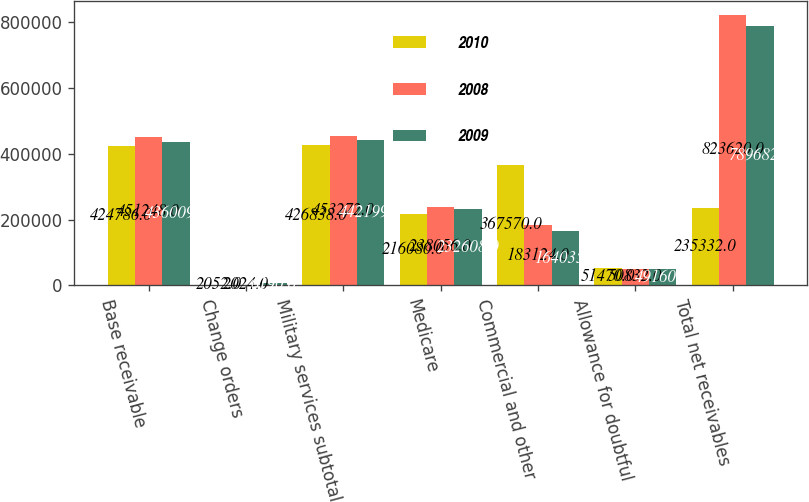<chart> <loc_0><loc_0><loc_500><loc_500><stacked_bar_chart><ecel><fcel>Base receivable<fcel>Change orders<fcel>Military services subtotal<fcel>Medicare<fcel>Commercial and other<fcel>Allowance for doubtful<fcel>Total net receivables<nl><fcel>2010<fcel>424786<fcel>2052<fcel>426838<fcel>216080<fcel>367570<fcel>51470<fcel>235332<nl><fcel>2008<fcel>451248<fcel>2024<fcel>453272<fcel>238056<fcel>183124<fcel>50832<fcel>823620<nl><fcel>2009<fcel>436009<fcel>6190<fcel>442199<fcel>232608<fcel>164035<fcel>49160<fcel>789682<nl></chart> 